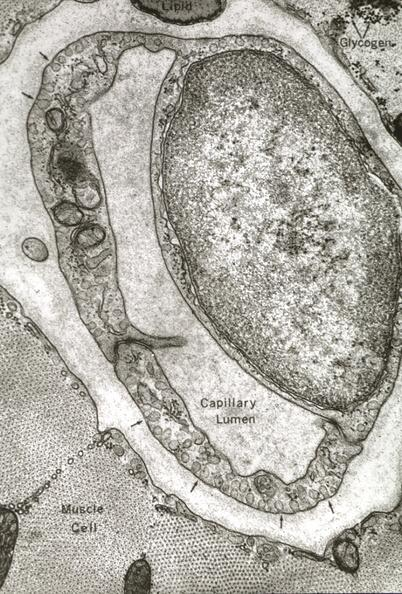what is present?
Answer the question using a single word or phrase. Vasculature 